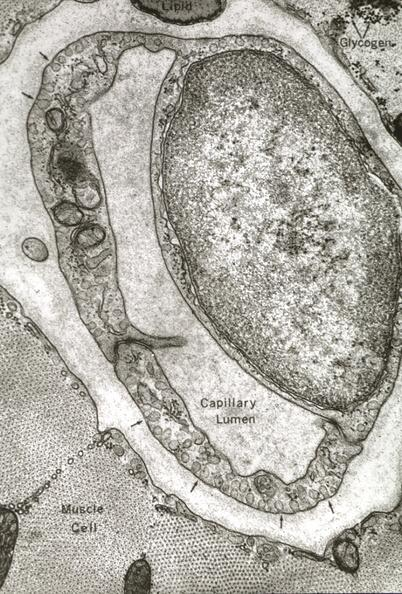what is present?
Answer the question using a single word or phrase. Vasculature 